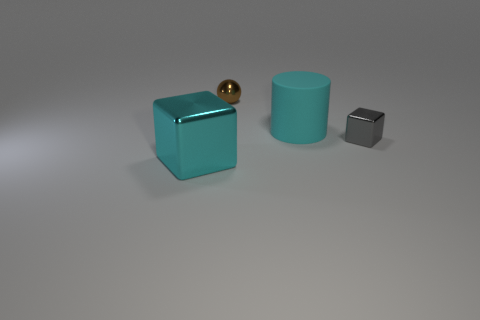Is there any other thing that is made of the same material as the big cyan cylinder?
Offer a terse response. No. Does the object that is on the right side of the cyan cylinder have the same material as the cyan thing that is right of the small brown metallic sphere?
Keep it short and to the point. No. What shape is the gray thing?
Keep it short and to the point. Cube. Are there an equal number of tiny shiny blocks in front of the small gray block and large green blocks?
Your answer should be very brief. Yes. There is a shiny cube that is the same color as the cylinder; what is its size?
Offer a terse response. Large. Are there any brown objects made of the same material as the small brown ball?
Offer a terse response. No. There is a shiny object that is to the left of the brown ball; is its shape the same as the tiny metal object that is right of the tiny brown metal sphere?
Ensure brevity in your answer.  Yes. Are any cubes visible?
Offer a very short reply. Yes. There is a object that is the same size as the cyan shiny block; what color is it?
Offer a terse response. Cyan. What number of other objects are the same shape as the gray metal object?
Provide a succinct answer. 1. 